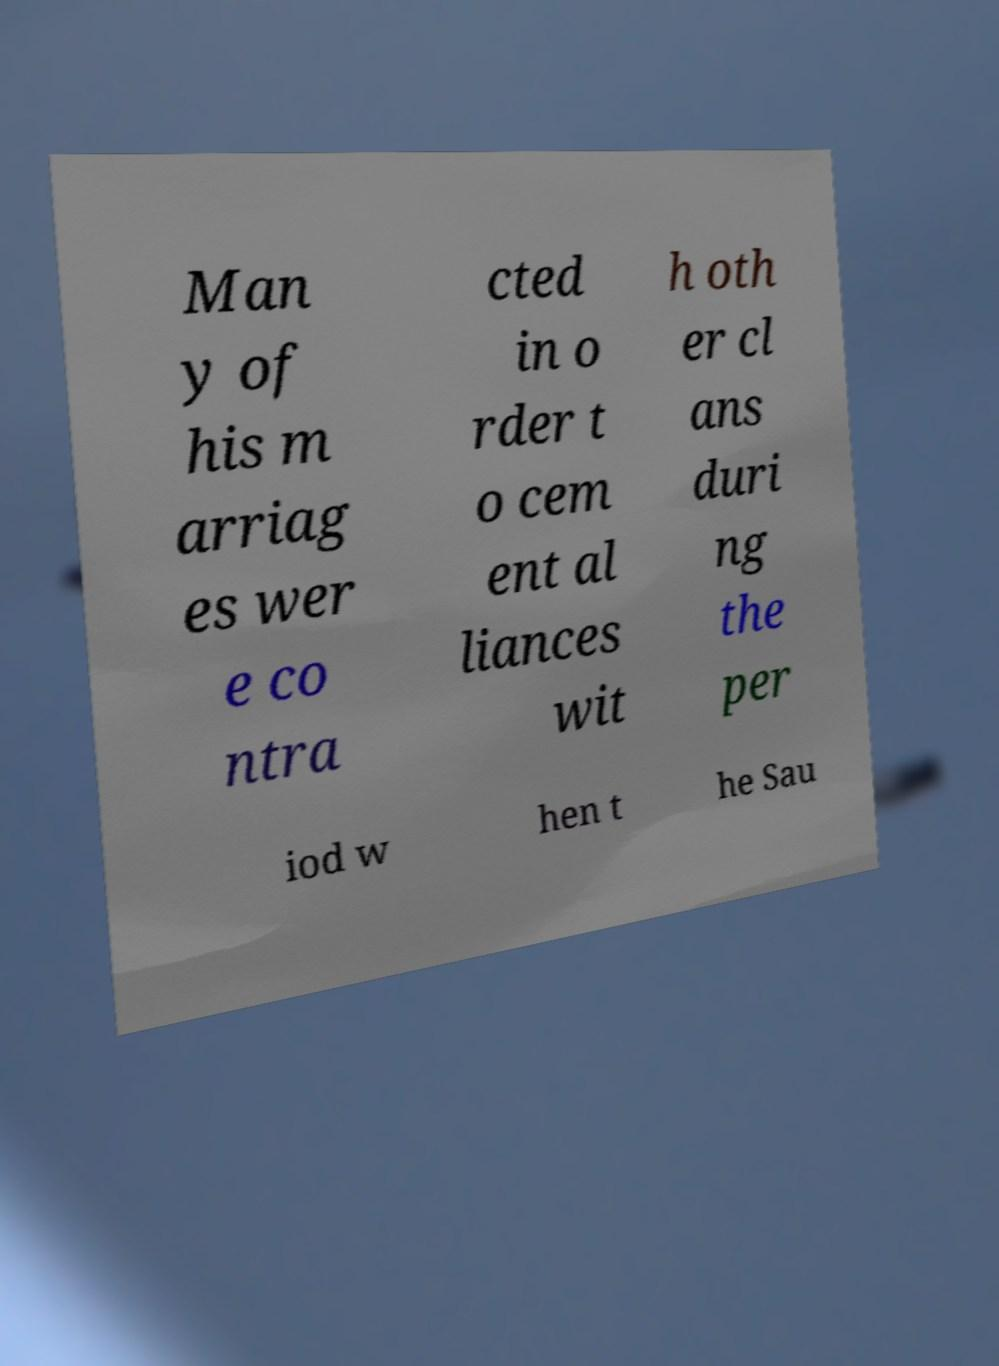Can you accurately transcribe the text from the provided image for me? Man y of his m arriag es wer e co ntra cted in o rder t o cem ent al liances wit h oth er cl ans duri ng the per iod w hen t he Sau 